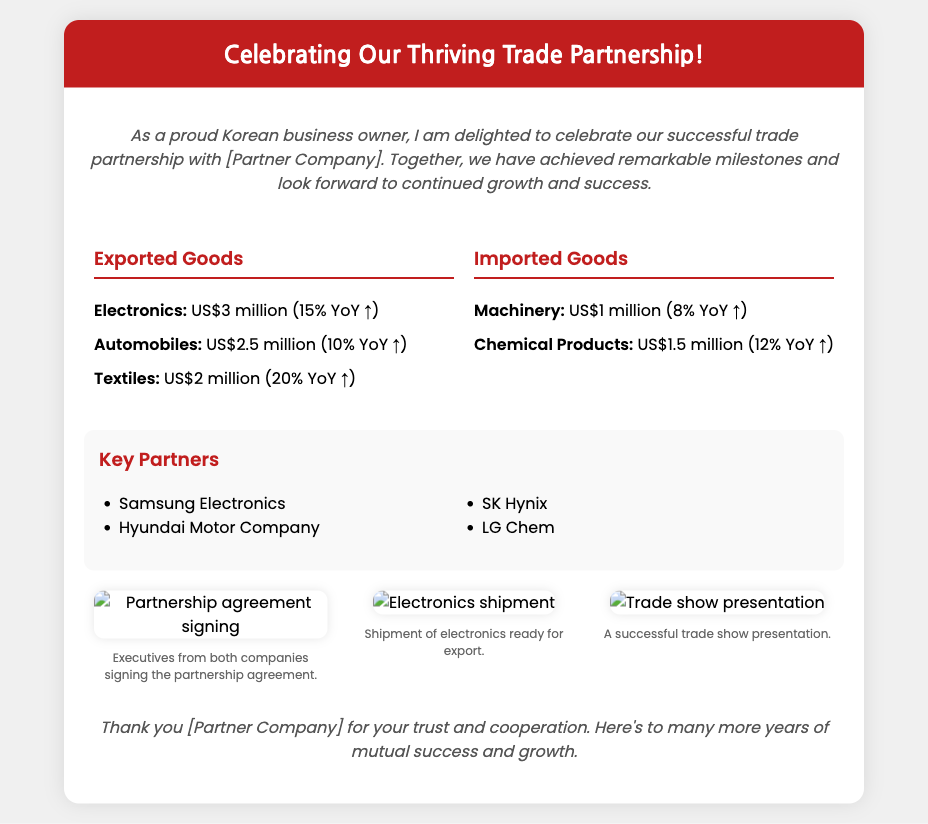What is the title of the card? The title of the card is prominently displayed in the header section.
Answer: Celebrating Our Thriving Trade Partnership! Which company is being celebrated in the card? The card mentions the partner company for collaboration several times in the content but does not specify a name.
Answer: [Partner Company] How much were the exported electronics worth? The document provides specific figures for exported goods, particularly electronics.
Answer: US$3 million What was the year-over-year increase for textiles? The year-over-year percentage increase for textiles is noted in the document under exported goods.
Answer: 20% YoY ↑ Who is one of the key partners listed in the card? The partners are specifically enumerated in the section about key partners.
Answer: Samsung Electronics How many categories are highlighted under imported goods? The document lists the categories of imported goods in a specific section.
Answer: 2 What is the total amount of imported machinery? The exact figure is provided for the category of imported machinery in the document.
Answer: US$1 million What is the main purpose of the photos included in the card? The captions accompanying the photos describe the context of each image, indicating their purpose.
Answer: Showcasing partnership activities How many photos are included in the card? The document specifies the number of photos presented in the photos section.
Answer: 3 What color is the header background? The color of the header background can be found in the CSS styling and the visual impression of the document.
Answer: #c11e1e 